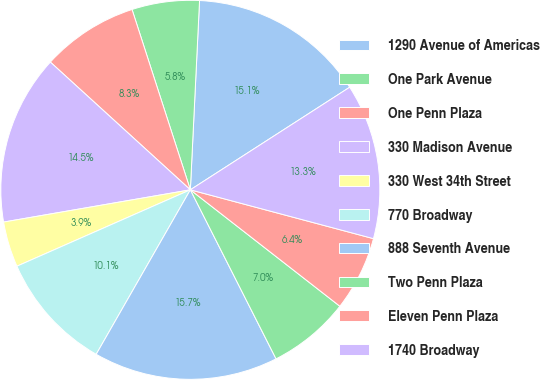<chart> <loc_0><loc_0><loc_500><loc_500><pie_chart><fcel>1290 Avenue of Americas<fcel>One Park Avenue<fcel>One Penn Plaza<fcel>330 Madison Avenue<fcel>330 West 34th Street<fcel>770 Broadway<fcel>888 Seventh Avenue<fcel>Two Penn Plaza<fcel>Eleven Penn Plaza<fcel>1740 Broadway<nl><fcel>15.12%<fcel>5.75%<fcel>8.25%<fcel>14.49%<fcel>3.88%<fcel>10.12%<fcel>15.74%<fcel>7.0%<fcel>6.38%<fcel>13.25%<nl></chart> 